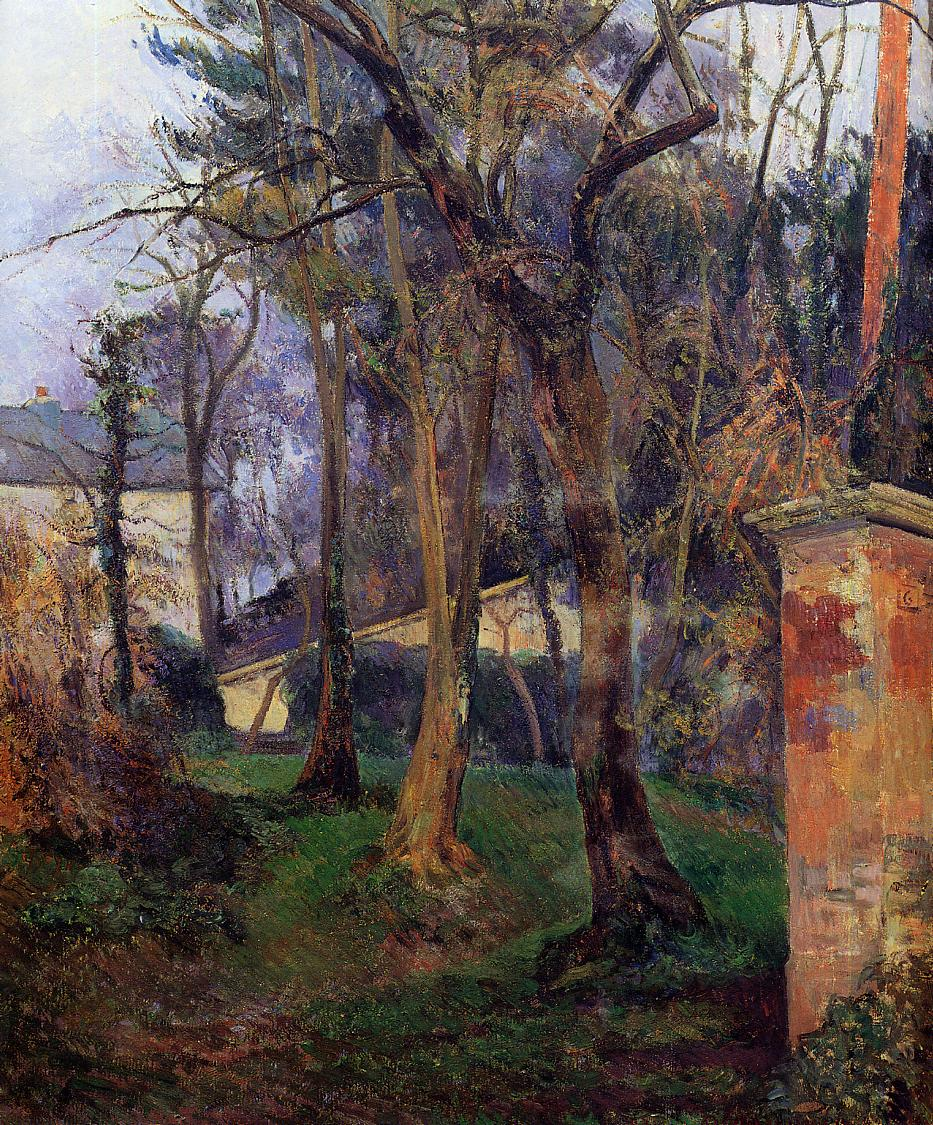What might be the emotional or thematic significance of this piece? The painting could be interpreted as an exploration of tranquility and solitude within nature. The overgrown, untamed garden and the towering trees create a secluded, almost hidden space, suggesting a retreat from the bustling outside world. The interplay of light and shadow, along with the naturalistic colors and textures, might evoke feelings of contemplation or reflection, inviting the viewer to consider the serene and ephemeral qualities of nature and perhaps, by extension, life itself. 